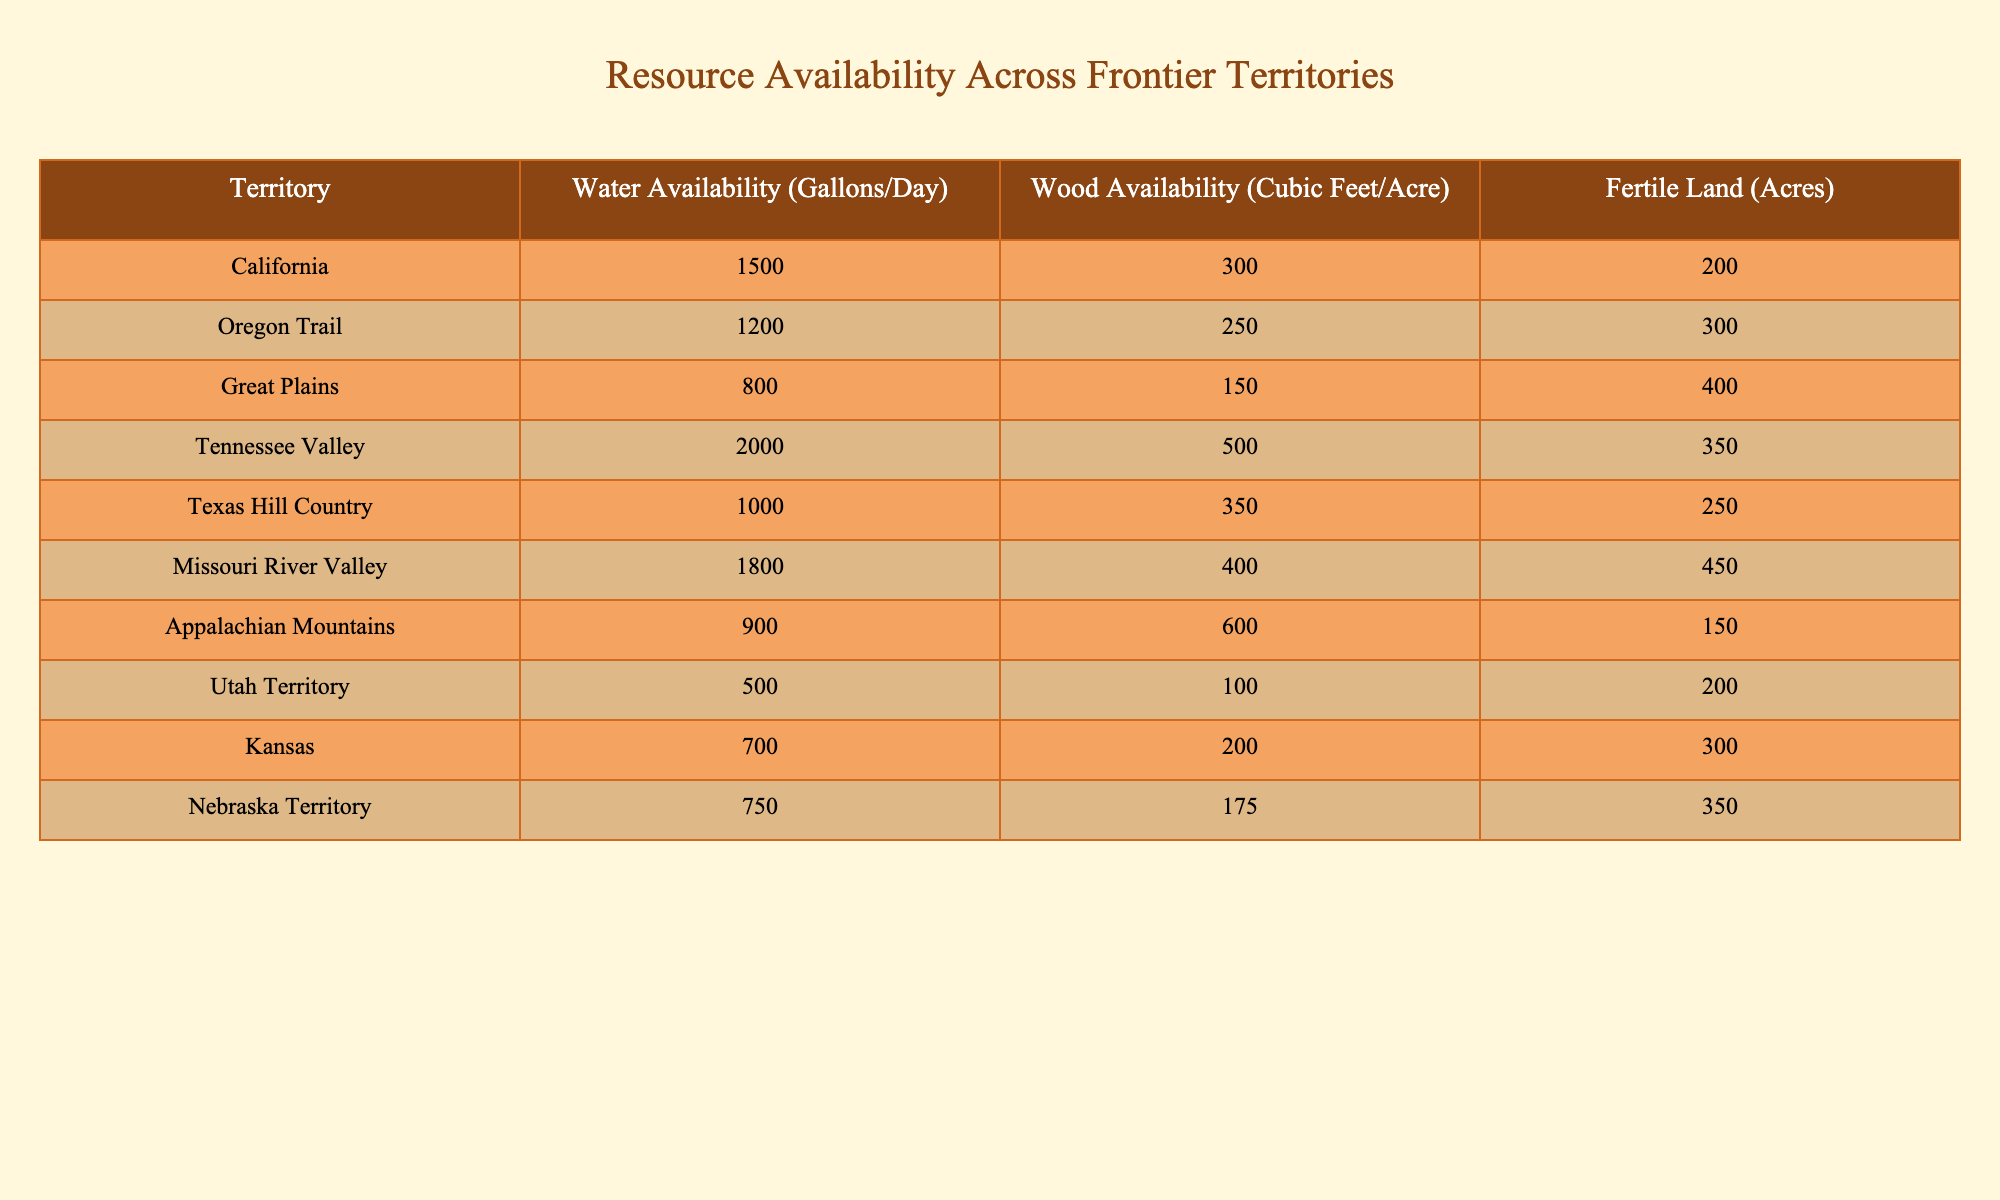What is the water availability in the Tennessee Valley? The table lists the water availability for each territory. For the Tennessee Valley, it shows 2000 gallons per day.
Answer: 2000 gallons per day Which territory has the highest wood availability? Comparing the wood availability across all territories, the Appalachian Mountains has the highest value at 600 cubic feet per acre.
Answer: Appalachian Mountains What is the total water availability for the Great Plains and Kansas combined? The water availability for the Great Plains is 800 gallons per day and for Kansas, it is 700 gallons per day. Adding these together gives 800 + 700 = 1500 gallons per day.
Answer: 1500 gallons per day Is there fertile land in the Utah Territory? The Utah Territory has 200 acres of fertile land listed in the table, which means it does have fertile land available.
Answer: Yes What is the average wood availability across all territories? To find the average, first sum the wood availability values from all territories: 300 + 250 + 150 + 500 + 350 + 400 + 600 + 100 + 200 + 175 = 2675 cubic feet. There are 10 territories, so the average is 2675/10 = 267.5 cubic feet per acre.
Answer: 267.5 cubic feet per acre Which territory has the least amount of fertile land? By looking at the table, the Utah Territory has the least amount of fertile land with only 200 acres available.
Answer: Utah Territory What is the difference in fertile land between the Missouri River Valley and the Oregon Trail? The Missouri River Valley has 450 acres of fertile land, while the Oregon Trail has 300 acres. The difference is 450 - 300 = 150 acres.
Answer: 150 acres Does the Texas Hill Country have more wood availability than the Great Plains? The Texas Hill Country has 350 cubic feet per acre of wood, whereas the Great Plains has only 150 cubic feet per acre. Thus, Texas Hill Country does have more wood availability.
Answer: Yes Which territory has the lowest water availability, and what is that value? Looking through the water availability values, the Utah Territory shows the lowest availability at 500 gallons per day.
Answer: Utah Territory, 500 gallons per day 